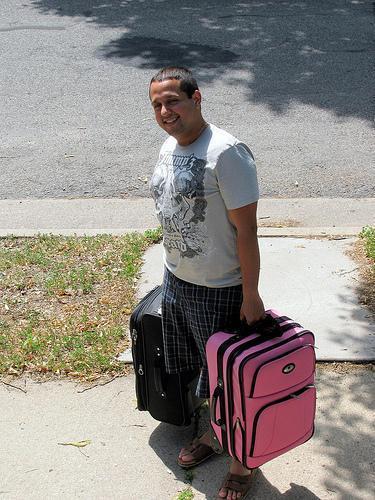How many suitcases is the man carrying?
Give a very brief answer. 2. 